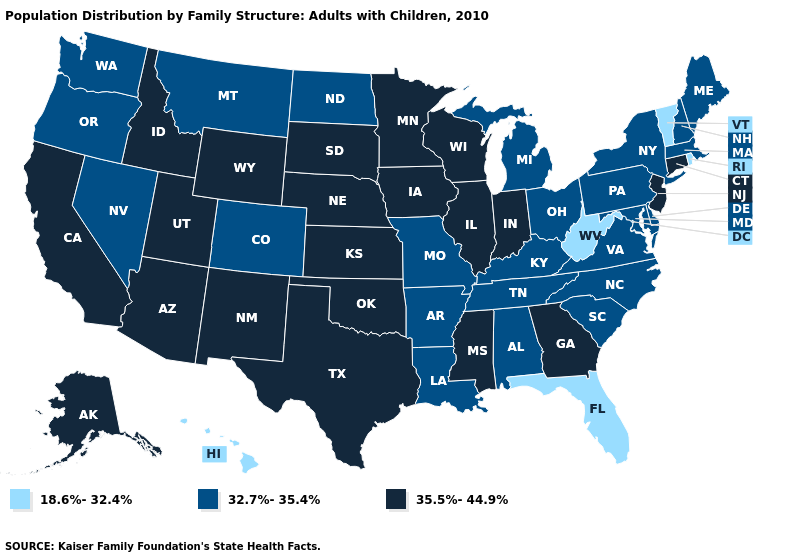How many symbols are there in the legend?
Concise answer only. 3. What is the value of Oregon?
Answer briefly. 32.7%-35.4%. Name the states that have a value in the range 32.7%-35.4%?
Give a very brief answer. Alabama, Arkansas, Colorado, Delaware, Kentucky, Louisiana, Maine, Maryland, Massachusetts, Michigan, Missouri, Montana, Nevada, New Hampshire, New York, North Carolina, North Dakota, Ohio, Oregon, Pennsylvania, South Carolina, Tennessee, Virginia, Washington. Which states have the lowest value in the Northeast?
Concise answer only. Rhode Island, Vermont. Does Washington have the highest value in the West?
Answer briefly. No. Name the states that have a value in the range 35.5%-44.9%?
Quick response, please. Alaska, Arizona, California, Connecticut, Georgia, Idaho, Illinois, Indiana, Iowa, Kansas, Minnesota, Mississippi, Nebraska, New Jersey, New Mexico, Oklahoma, South Dakota, Texas, Utah, Wisconsin, Wyoming. Name the states that have a value in the range 18.6%-32.4%?
Concise answer only. Florida, Hawaii, Rhode Island, Vermont, West Virginia. What is the value of Indiana?
Write a very short answer. 35.5%-44.9%. Among the states that border Massachusetts , which have the lowest value?
Short answer required. Rhode Island, Vermont. What is the value of Idaho?
Keep it brief. 35.5%-44.9%. What is the value of South Dakota?
Short answer required. 35.5%-44.9%. Among the states that border South Carolina , does North Carolina have the highest value?
Answer briefly. No. Does Florida have the lowest value in the USA?
Quick response, please. Yes. What is the value of Wyoming?
Short answer required. 35.5%-44.9%. What is the value of Washington?
Keep it brief. 32.7%-35.4%. 